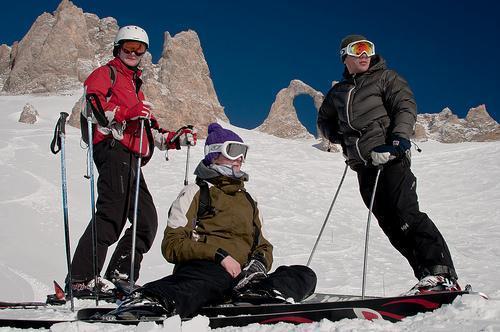How many people are there?
Give a very brief answer. 3. 